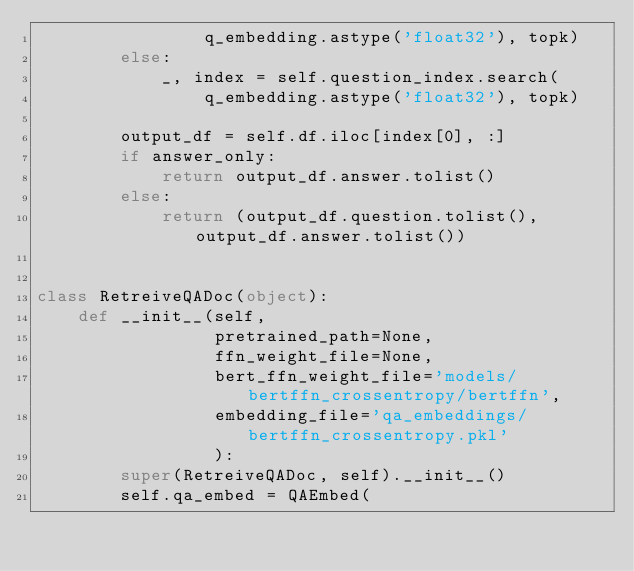<code> <loc_0><loc_0><loc_500><loc_500><_Python_>                q_embedding.astype('float32'), topk)
        else:
            _, index = self.question_index.search(
                q_embedding.astype('float32'), topk)

        output_df = self.df.iloc[index[0], :]
        if answer_only:
            return output_df.answer.tolist()
        else:
            return (output_df.question.tolist(), output_df.answer.tolist())


class RetreiveQADoc(object):
    def __init__(self,
                 pretrained_path=None,
                 ffn_weight_file=None,
                 bert_ffn_weight_file='models/bertffn_crossentropy/bertffn',
                 embedding_file='qa_embeddings/bertffn_crossentropy.pkl'
                 ):
        super(RetreiveQADoc, self).__init__()
        self.qa_embed = QAEmbed(</code> 